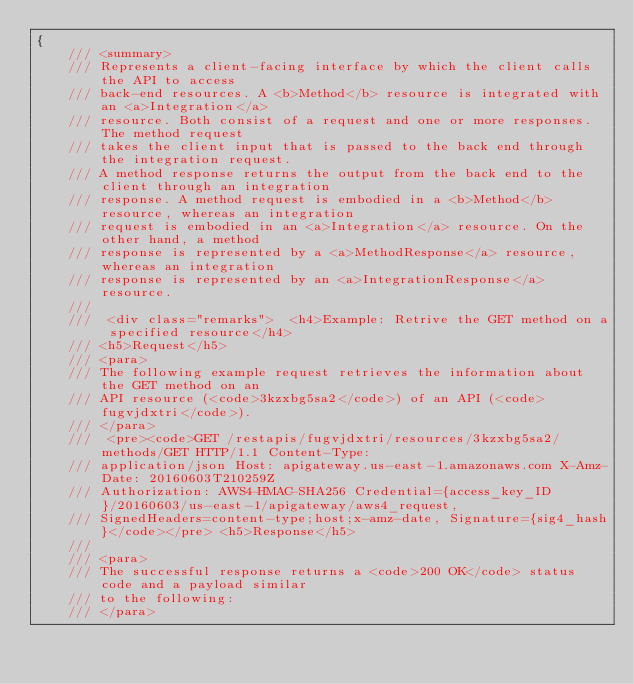Convert code to text. <code><loc_0><loc_0><loc_500><loc_500><_C#_>{
    /// <summary>
    /// Represents a client-facing interface by which the client calls the API to access
    /// back-end resources. A <b>Method</b> resource is integrated with an <a>Integration</a>
    /// resource. Both consist of a request and one or more responses. The method request
    /// takes the client input that is passed to the back end through the integration request.
    /// A method response returns the output from the back end to the client through an integration
    /// response. A method request is embodied in a <b>Method</b> resource, whereas an integration
    /// request is embodied in an <a>Integration</a> resource. On the other hand, a method
    /// response is represented by a <a>MethodResponse</a> resource, whereas an integration
    /// response is represented by an <a>IntegrationResponse</a> resource. 
    /// 
    ///  <div class="remarks">  <h4>Example: Retrive the GET method on a specified resource</h4>
    /// <h5>Request</h5> 
    /// <para>
    /// The following example request retrieves the information about the GET method on an
    /// API resource (<code>3kzxbg5sa2</code>) of an API (<code>fugvjdxtri</code>). 
    /// </para>
    ///  <pre><code>GET /restapis/fugvjdxtri/resources/3kzxbg5sa2/methods/GET HTTP/1.1 Content-Type:
    /// application/json Host: apigateway.us-east-1.amazonaws.com X-Amz-Date: 20160603T210259Z
    /// Authorization: AWS4-HMAC-SHA256 Credential={access_key_ID}/20160603/us-east-1/apigateway/aws4_request,
    /// SignedHeaders=content-type;host;x-amz-date, Signature={sig4_hash}</code></pre> <h5>Response</h5>
    /// 
    /// <para>
    /// The successful response returns a <code>200 OK</code> status code and a payload similar
    /// to the following:
    /// </para></code> 